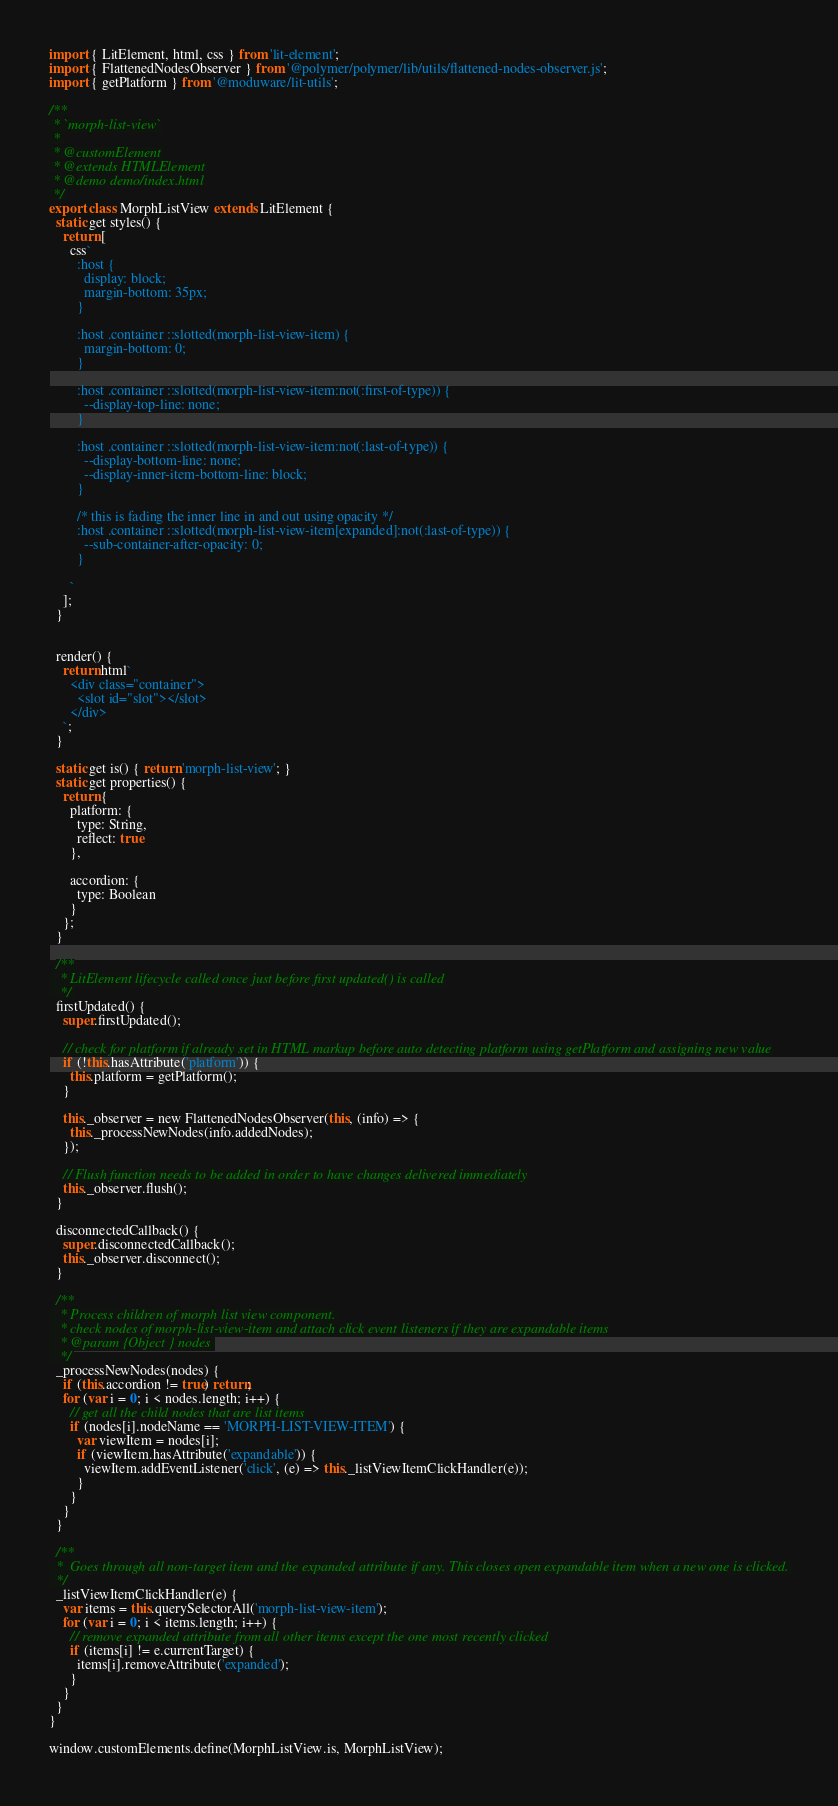Convert code to text. <code><loc_0><loc_0><loc_500><loc_500><_JavaScript_>import { LitElement, html, css } from 'lit-element';
import { FlattenedNodesObserver } from '@polymer/polymer/lib/utils/flattened-nodes-observer.js';
import { getPlatform } from '@moduware/lit-utils';

/**
 * `morph-list-view`
 * 
 * @customElement
 * @extends HTMLElement
 * @demo demo/index.html
 */
export class MorphListView extends LitElement {
  static get styles() {
    return [
      css`
        :host {
          display: block;
          margin-bottom: 35px;
        }
      
        :host .container ::slotted(morph-list-view-item) {
          margin-bottom: 0;
        }
      
        :host .container ::slotted(morph-list-view-item:not(:first-of-type)) {
          --display-top-line: none;
        }
      
        :host .container ::slotted(morph-list-view-item:not(:last-of-type)) {
          --display-bottom-line: none;
          --display-inner-item-bottom-line: block;
        }
        
        /* this is fading the inner line in and out using opacity */
        :host .container ::slotted(morph-list-view-item[expanded]:not(:last-of-type)) {
          --sub-container-after-opacity: 0;
        }
      
      `
    ];
  }


  render() {
    return html`
      <div class="container">
        <slot id="slot"></slot>
      </div>
    `;
  }

  static get is() { return 'morph-list-view'; }
  static get properties() {
    return {
      platform: {
        type: String,
        reflect: true
      },

      accordion: {
        type: Boolean
      }
    };
  }

  /**
   * LitElement lifecycle called once just before first updated() is called
   */
  firstUpdated() {
    super.firstUpdated();

    // check for platform if already set in HTML markup before auto detecting platform using getPlatform and assigning new value
    if (!this.hasAttribute('platform')) {
      this.platform = getPlatform();
    }

    this._observer = new FlattenedNodesObserver(this, (info) => {
      this._processNewNodes(info.addedNodes);
    });

    // Flush function needs to be added in order to have changes delivered immediately
    this._observer.flush();
  }

  disconnectedCallback() {
    super.disconnectedCallback();
    this._observer.disconnect();
  }

  /**
   * Process children of morph list view component. 
   * check nodes of morph-list-view-item and attach click event listeners if they are expandable items
   * @param {Object } nodes 
   */
  _processNewNodes(nodes) {
    if (this.accordion != true) return;
    for (var i = 0; i < nodes.length; i++) {
      // get all the child nodes that are list items
      if (nodes[i].nodeName == 'MORPH-LIST-VIEW-ITEM') {
        var viewItem = nodes[i];
        if (viewItem.hasAttribute('expandable')) {
          viewItem.addEventListener('click', (e) => this._listViewItemClickHandler(e));
        }
      } 
    }
  }

  /**
  *  Goes through all non-target item and the expanded attribute if any. This closes open expandable item when a new one is clicked. 
  */
  _listViewItemClickHandler(e) {
    var items = this.querySelectorAll('morph-list-view-item');
    for (var i = 0; i < items.length; i++) {
      // remove expanded attribute from all other items except the one most recently clicked
      if (items[i] != e.currentTarget) {
        items[i].removeAttribute('expanded');
      }
    }
  }
}

window.customElements.define(MorphListView.is, MorphListView);
</code> 